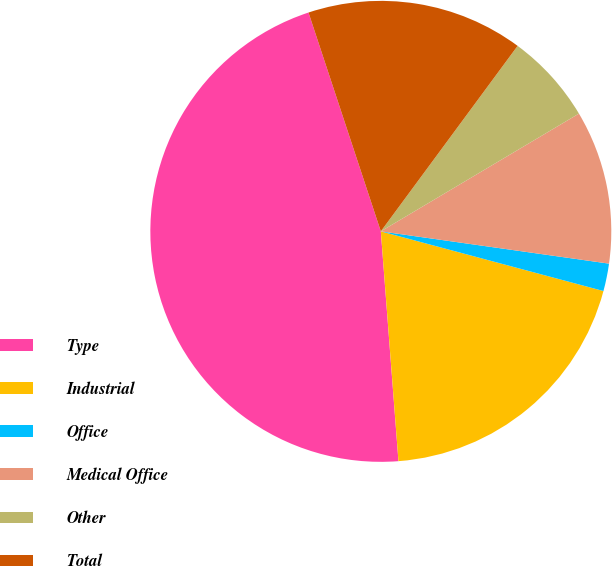Convert chart to OTSL. <chart><loc_0><loc_0><loc_500><loc_500><pie_chart><fcel>Type<fcel>Industrial<fcel>Office<fcel>Medical Office<fcel>Other<fcel>Total<nl><fcel>46.13%<fcel>19.61%<fcel>1.93%<fcel>10.77%<fcel>6.35%<fcel>15.19%<nl></chart> 